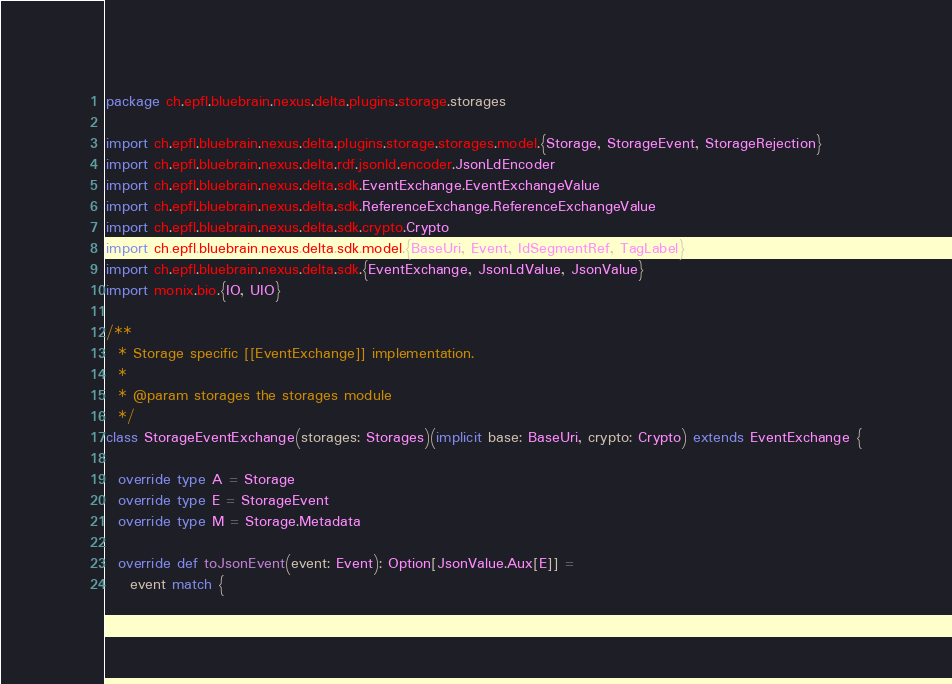<code> <loc_0><loc_0><loc_500><loc_500><_Scala_>package ch.epfl.bluebrain.nexus.delta.plugins.storage.storages

import ch.epfl.bluebrain.nexus.delta.plugins.storage.storages.model.{Storage, StorageEvent, StorageRejection}
import ch.epfl.bluebrain.nexus.delta.rdf.jsonld.encoder.JsonLdEncoder
import ch.epfl.bluebrain.nexus.delta.sdk.EventExchange.EventExchangeValue
import ch.epfl.bluebrain.nexus.delta.sdk.ReferenceExchange.ReferenceExchangeValue
import ch.epfl.bluebrain.nexus.delta.sdk.crypto.Crypto
import ch.epfl.bluebrain.nexus.delta.sdk.model.{BaseUri, Event, IdSegmentRef, TagLabel}
import ch.epfl.bluebrain.nexus.delta.sdk.{EventExchange, JsonLdValue, JsonValue}
import monix.bio.{IO, UIO}

/**
  * Storage specific [[EventExchange]] implementation.
  *
  * @param storages the storages module
  */
class StorageEventExchange(storages: Storages)(implicit base: BaseUri, crypto: Crypto) extends EventExchange {

  override type A = Storage
  override type E = StorageEvent
  override type M = Storage.Metadata

  override def toJsonEvent(event: Event): Option[JsonValue.Aux[E]] =
    event match {</code> 